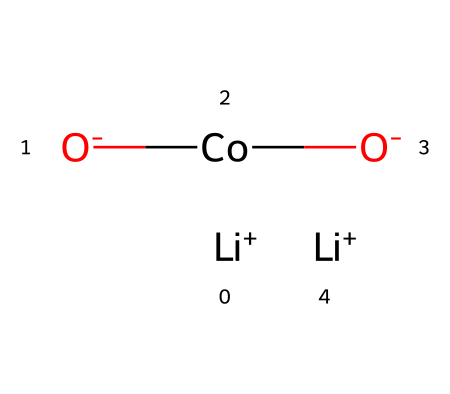What is the molecular formula for lithium cobalt oxide? The provided SMILES representation breaks down into Li, Co, and O atoms, indicating the chemical composition, which leads to the overall formula of LiCoO2.
Answer: LiCoO2 How many lithium ions are present in the structure? Upon analyzing the SMILES representation, there are two [Li+] ions indicated in the formula, confirming the presence of two lithium atoms.
Answer: 2 What type of bonds are present in lithium cobalt oxide? The structure consists of ionic bonds between the lithium ions and the cobalt oxide framework, with covalent interactions suggested by the transition metal's presence.
Answer: ionic How many oxygen atoms are involved in the structure? The SMILES shows two [O-] atoms associated with the cobalt atom, so there are a total of two oxygen atoms in the structure.
Answer: 2 What role does cobalt play in lithium cobalt oxide? Cobalt acts as a transition metal within the structure, contributing to the electronic properties and facilitating lithium ion intercalation, which is essential for battery function.
Answer: transition metal Is this compound a good conductor of electricity? The presence of freely moving lithium ions within the structured lattice suggests it has conductivity properties, allowing it to perform well as a cathode material in batteries.
Answer: yes What structural feature typically allows lithium cobalt oxide to function effectively in batteries? The layered structure of lithium cobalt oxide allows for the intercalation and deintercalation of lithium ions, making it optimal for rechargeable battery applications.
Answer: layered structure 